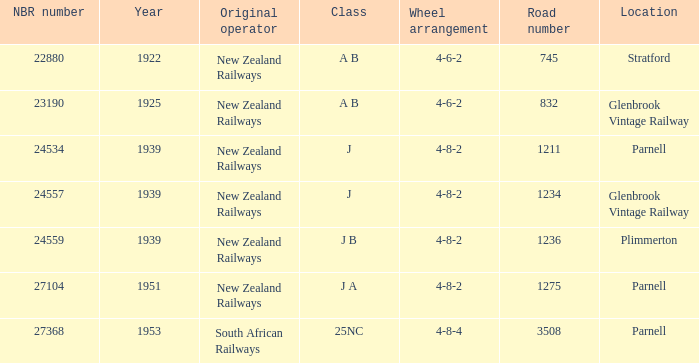Give me the full table as a dictionary. {'header': ['NBR number', 'Year', 'Original operator', 'Class', 'Wheel arrangement', 'Road number', 'Location'], 'rows': [['22880', '1922', 'New Zealand Railways', 'A B', '4-6-2', '745', 'Stratford'], ['23190', '1925', 'New Zealand Railways', 'A B', '4-6-2', '832', 'Glenbrook Vintage Railway'], ['24534', '1939', 'New Zealand Railways', 'J', '4-8-2', '1211', 'Parnell'], ['24557', '1939', 'New Zealand Railways', 'J', '4-8-2', '1234', 'Glenbrook Vintage Railway'], ['24559', '1939', 'New Zealand Railways', 'J B', '4-8-2', '1236', 'Plimmerton'], ['27104', '1951', 'New Zealand Railways', 'J A', '4-8-2', '1275', 'Parnell'], ['27368', '1953', 'South African Railways', '25NC', '4-8-4', '3508', 'Parnell']]} How many road numerals are before 1922? 0.0. 